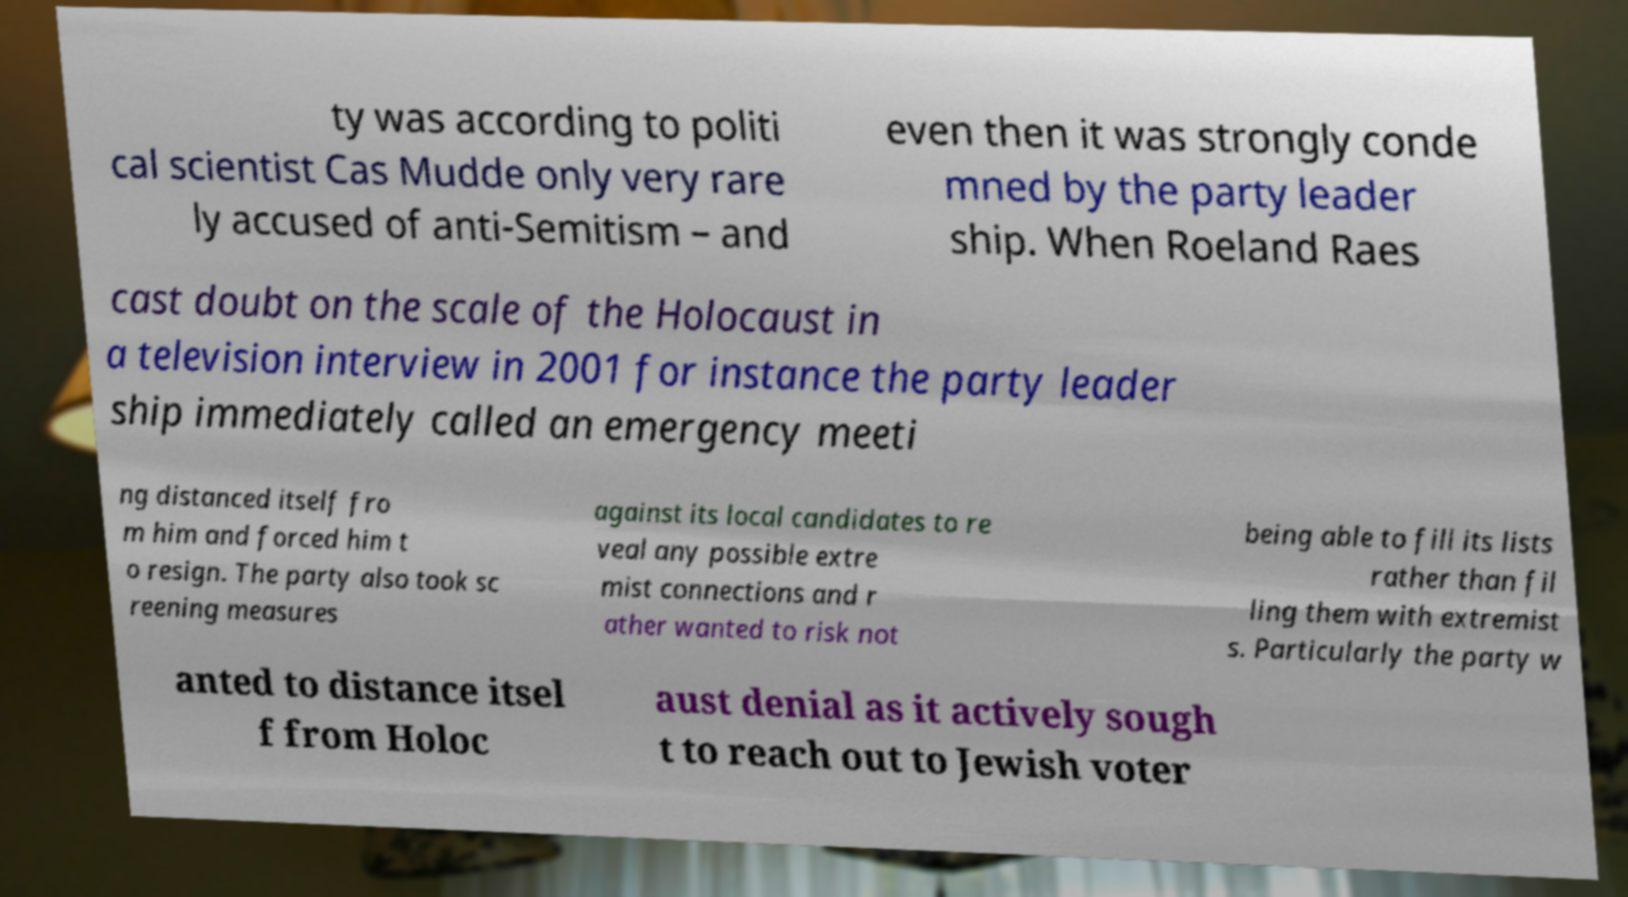I need the written content from this picture converted into text. Can you do that? ty was according to politi cal scientist Cas Mudde only very rare ly accused of anti-Semitism – and even then it was strongly conde mned by the party leader ship. When Roeland Raes cast doubt on the scale of the Holocaust in a television interview in 2001 for instance the party leader ship immediately called an emergency meeti ng distanced itself fro m him and forced him t o resign. The party also took sc reening measures against its local candidates to re veal any possible extre mist connections and r ather wanted to risk not being able to fill its lists rather than fil ling them with extremist s. Particularly the party w anted to distance itsel f from Holoc aust denial as it actively sough t to reach out to Jewish voter 